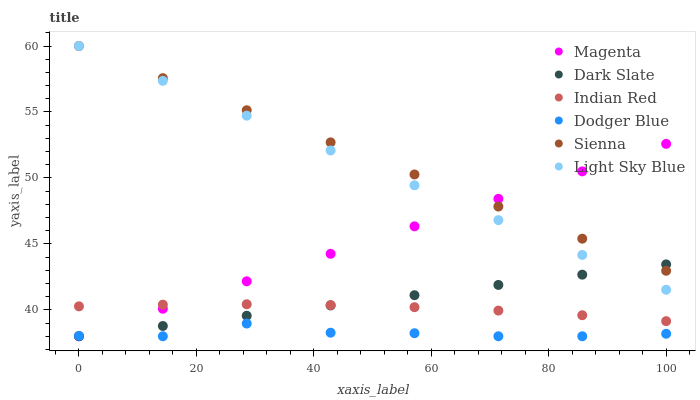Does Dodger Blue have the minimum area under the curve?
Answer yes or no. Yes. Does Sienna have the maximum area under the curve?
Answer yes or no. Yes. Does Dark Slate have the minimum area under the curve?
Answer yes or no. No. Does Dark Slate have the maximum area under the curve?
Answer yes or no. No. Is Magenta the smoothest?
Answer yes or no. Yes. Is Dodger Blue the roughest?
Answer yes or no. Yes. Is Dark Slate the smoothest?
Answer yes or no. No. Is Dark Slate the roughest?
Answer yes or no. No. Does Dark Slate have the lowest value?
Answer yes or no. Yes. Does Light Sky Blue have the lowest value?
Answer yes or no. No. Does Light Sky Blue have the highest value?
Answer yes or no. Yes. Does Dark Slate have the highest value?
Answer yes or no. No. Is Dodger Blue less than Sienna?
Answer yes or no. Yes. Is Sienna greater than Indian Red?
Answer yes or no. Yes. Does Dodger Blue intersect Dark Slate?
Answer yes or no. Yes. Is Dodger Blue less than Dark Slate?
Answer yes or no. No. Is Dodger Blue greater than Dark Slate?
Answer yes or no. No. Does Dodger Blue intersect Sienna?
Answer yes or no. No. 